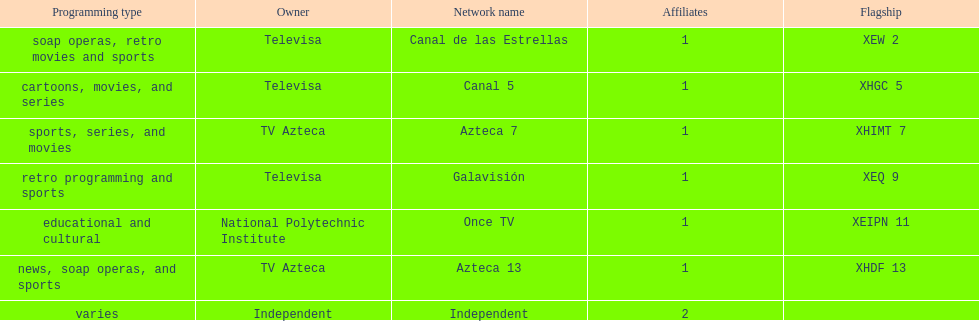How many affiliates does galavision have? 1. 